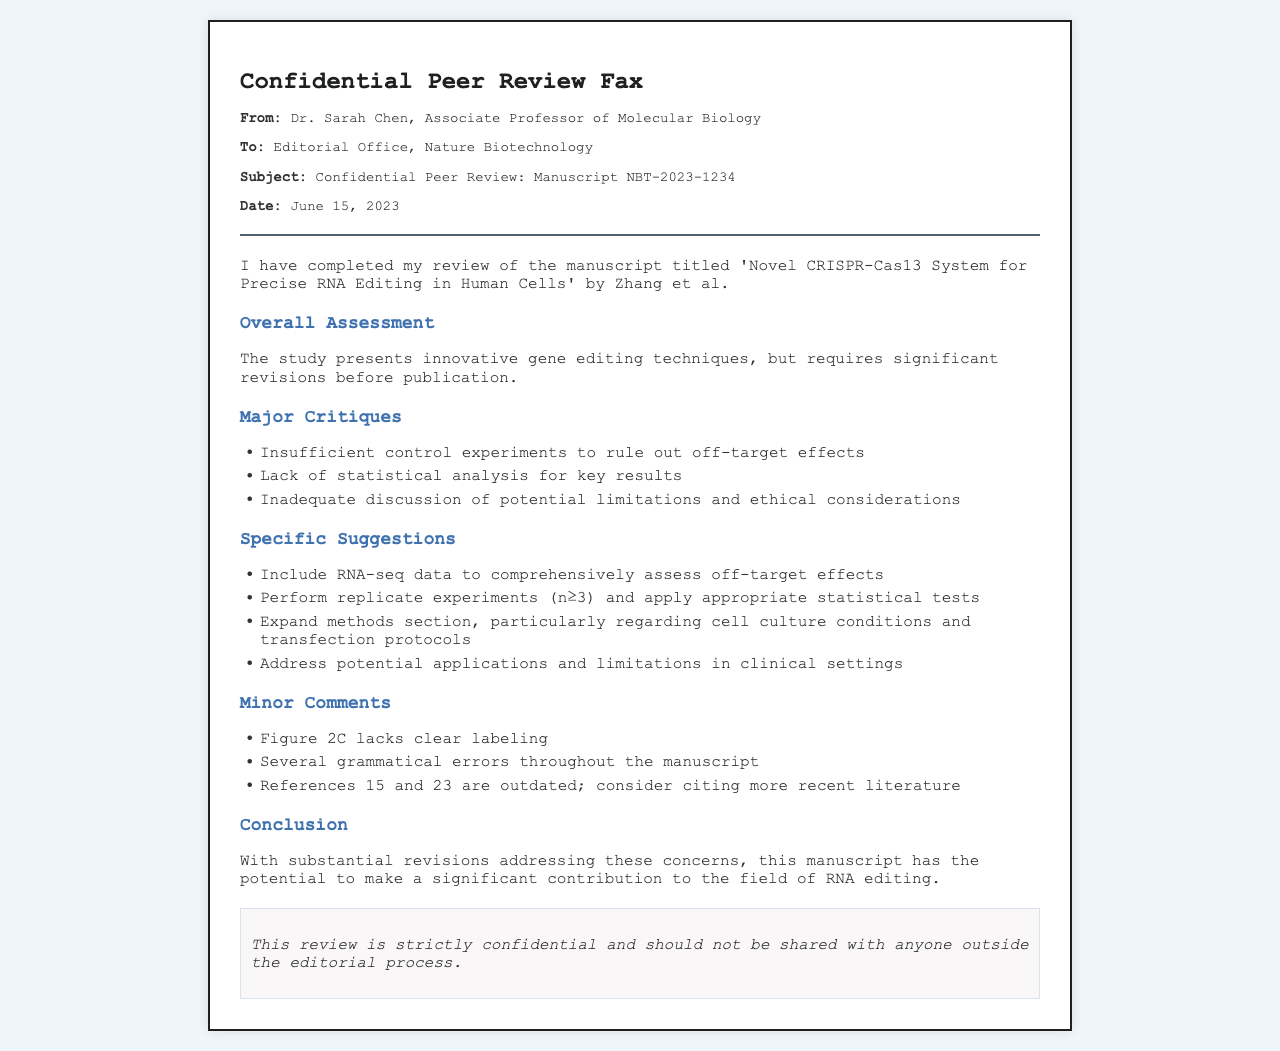What is the title of the manuscript? The title of the manuscript is provided in the document as 'Novel CRISPR-Cas13 System for Precise RNA Editing in Human Cells'.
Answer: 'Novel CRISPR-Cas13 System for Precise RNA Editing in Human Cells' Who is the reviewer of the manuscript? The reviewer is identified in the document as Dr. Sarah Chen, Associate Professor of Molecular Biology.
Answer: Dr. Sarah Chen What is the manuscript number? The manuscript number is specified in the document as NBT-2023-1234.
Answer: NBT-2023-1234 How many major critiques are mentioned? The document lists three major critiques, which can be counted for direct response.
Answer: 3 What date was the review completed? The completion date for the review is mentioned in the header of the document as June 15, 2023.
Answer: June 15, 2023 What type of statistical analysis is suggested? The reviewer suggests applying appropriate statistical tests as stated in the specific suggestions section.
Answer: Appropriate statistical tests What is one specific suggestion for improvement? The document recommends including RNA-seq data to comprehensively assess off-target effects as a specific suggestion.
Answer: Include RNA-seq data What are the identified minor comments regarding Figure 2C? The reviewer notes that Figure 2C lacks clear labeling as a minor comment in the document.
Answer: Lacks clear labeling What is the overall assessment of the manuscript? The overall assessment provided states that the study requires significant revisions before publication.
Answer: Requires significant revisions 